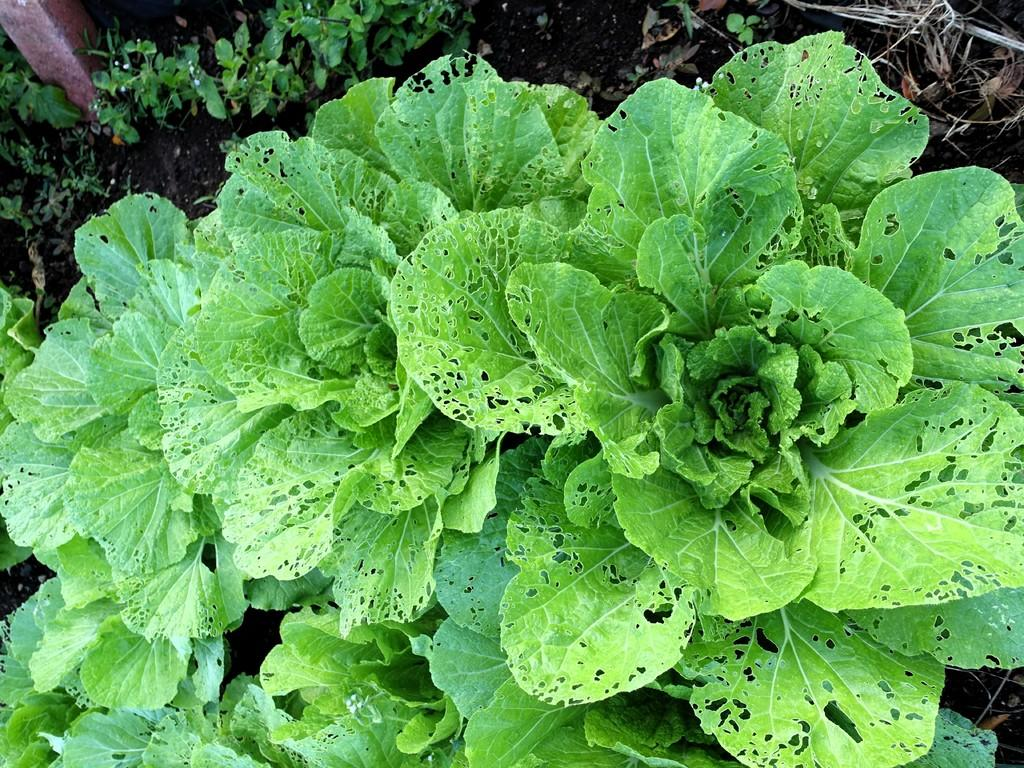What type of vegetable is present in the image? There is spinach in the image. What type of fuel is being used at the seashore in the image? There is no seashore or fuel present in the image; it only features spinach. 